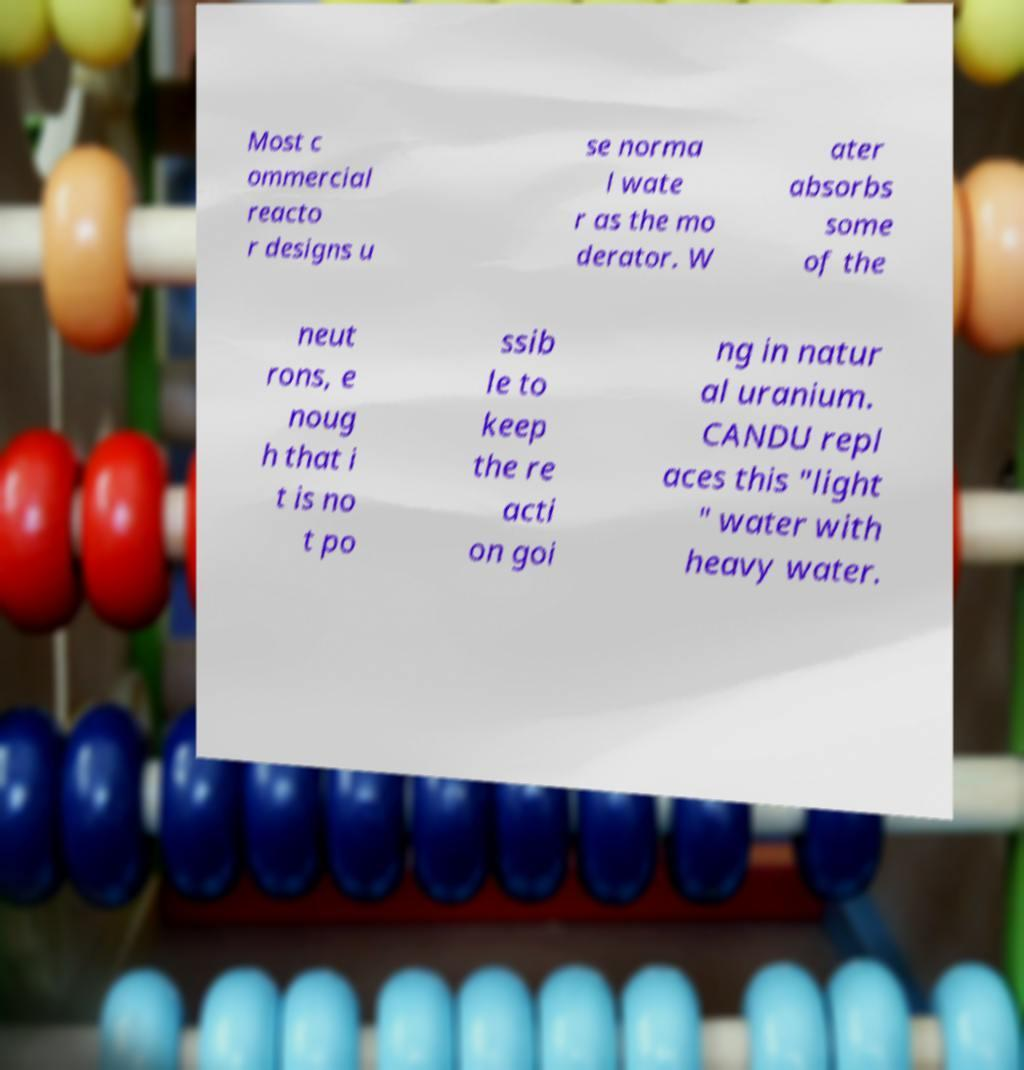Please read and relay the text visible in this image. What does it say? Most c ommercial reacto r designs u se norma l wate r as the mo derator. W ater absorbs some of the neut rons, e noug h that i t is no t po ssib le to keep the re acti on goi ng in natur al uranium. CANDU repl aces this "light " water with heavy water. 